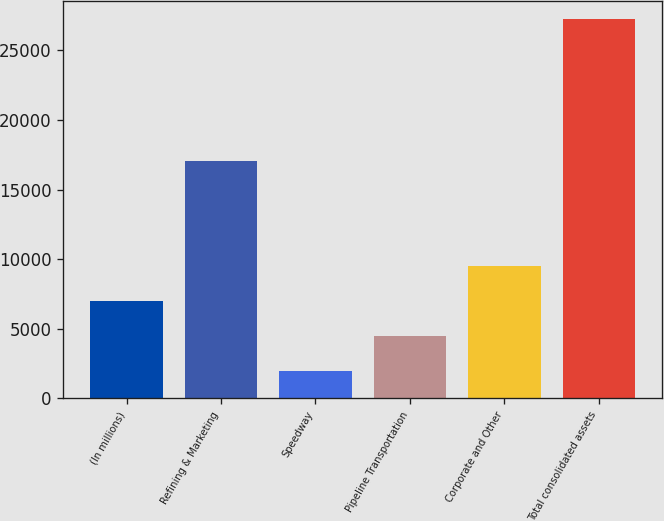Convert chart to OTSL. <chart><loc_0><loc_0><loc_500><loc_500><bar_chart><fcel>(In millions)<fcel>Refining & Marketing<fcel>Speedway<fcel>Pipeline Transportation<fcel>Corporate and Other<fcel>Total consolidated assets<nl><fcel>7002.2<fcel>17052<fcel>1947<fcel>4474.6<fcel>9529.8<fcel>27223<nl></chart> 